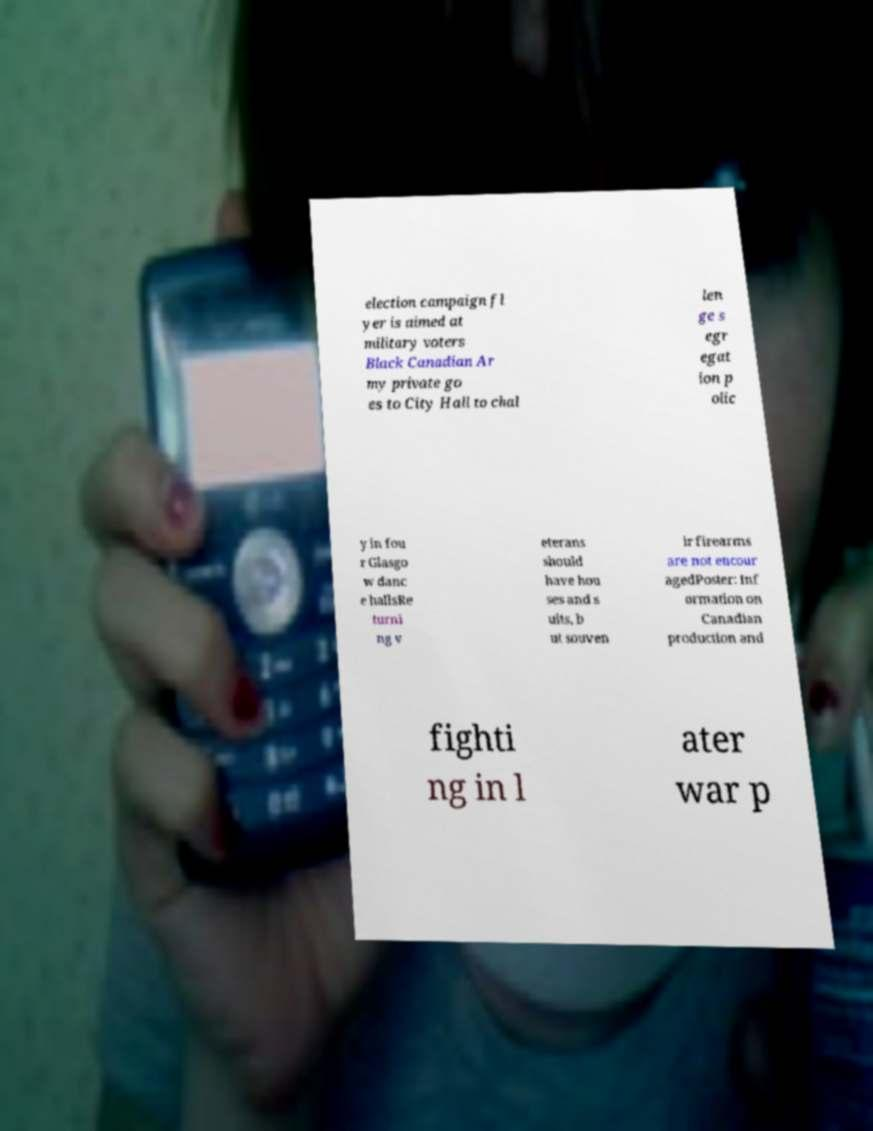Could you assist in decoding the text presented in this image and type it out clearly? election campaign fl yer is aimed at military voters Black Canadian Ar my private go es to City Hall to chal len ge s egr egat ion p olic y in fou r Glasgo w danc e hallsRe turni ng v eterans should have hou ses and s uits, b ut souven ir firearms are not encour agedPoster: Inf ormation on Canadian production and fighti ng in l ater war p 